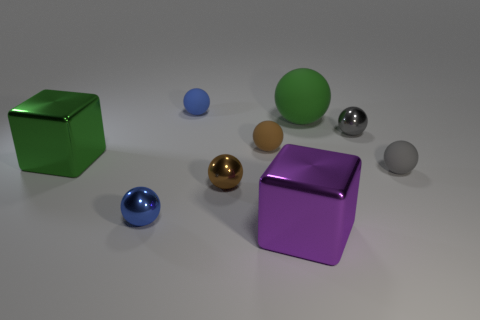What shape is the tiny matte thing that is both behind the gray matte thing and right of the tiny blue matte thing?
Provide a succinct answer. Sphere. What size is the object that is on the right side of the large sphere and on the left side of the gray rubber ball?
Provide a succinct answer. Small. There is a big green thing that is the same shape as the purple metallic thing; what is its material?
Give a very brief answer. Metal. There is a big green thing that is in front of the shiny object right of the large green ball; what is its material?
Give a very brief answer. Metal. There is a brown metallic object; is its shape the same as the blue thing left of the tiny blue rubber thing?
Provide a succinct answer. Yes. How many metal objects are either small blue balls or big purple things?
Keep it short and to the point. 2. What is the color of the big thing to the left of the blue object in front of the big shiny object behind the tiny gray matte ball?
Give a very brief answer. Green. What number of other objects are the same material as the green cube?
Your response must be concise. 4. Do the rubber object that is to the right of the large green ball and the large matte object have the same shape?
Provide a short and direct response. Yes. How many small objects are gray objects or rubber spheres?
Your answer should be very brief. 4. 